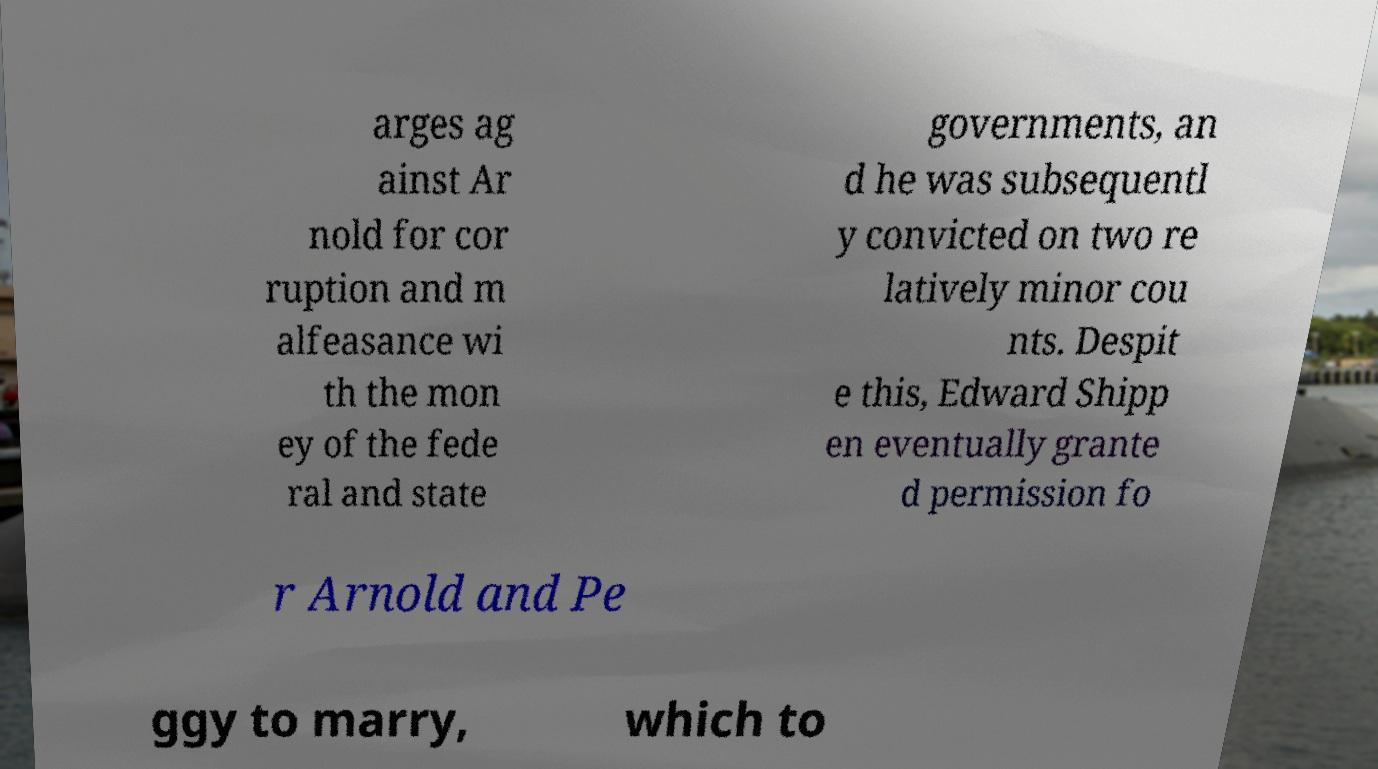I need the written content from this picture converted into text. Can you do that? arges ag ainst Ar nold for cor ruption and m alfeasance wi th the mon ey of the fede ral and state governments, an d he was subsequentl y convicted on two re latively minor cou nts. Despit e this, Edward Shipp en eventually grante d permission fo r Arnold and Pe ggy to marry, which to 